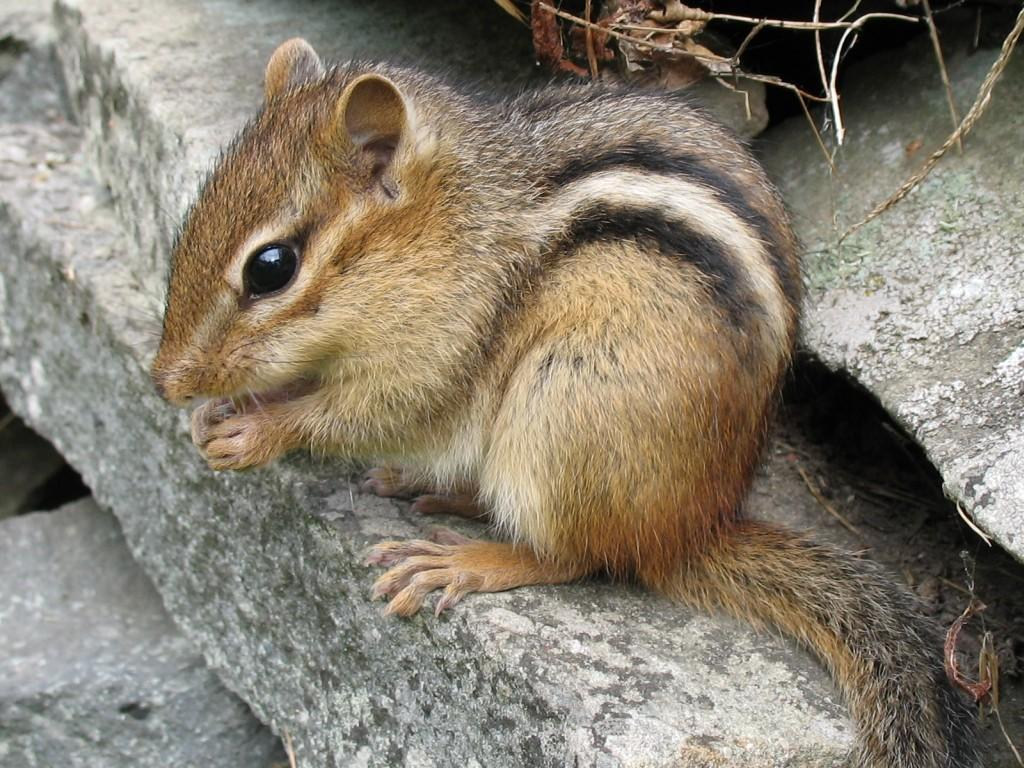What animal can be seen in the image? There is a squirrel in the image. Where is the squirrel located? The squirrel is on a rock. What type of vegetation can be seen at the top of the image? There are dried stems visible at the top of the image. How many plates are stacked on the rock next to the squirrel? There are no plates present in the image; it only features a squirrel on a rock and dried stems at the top. 